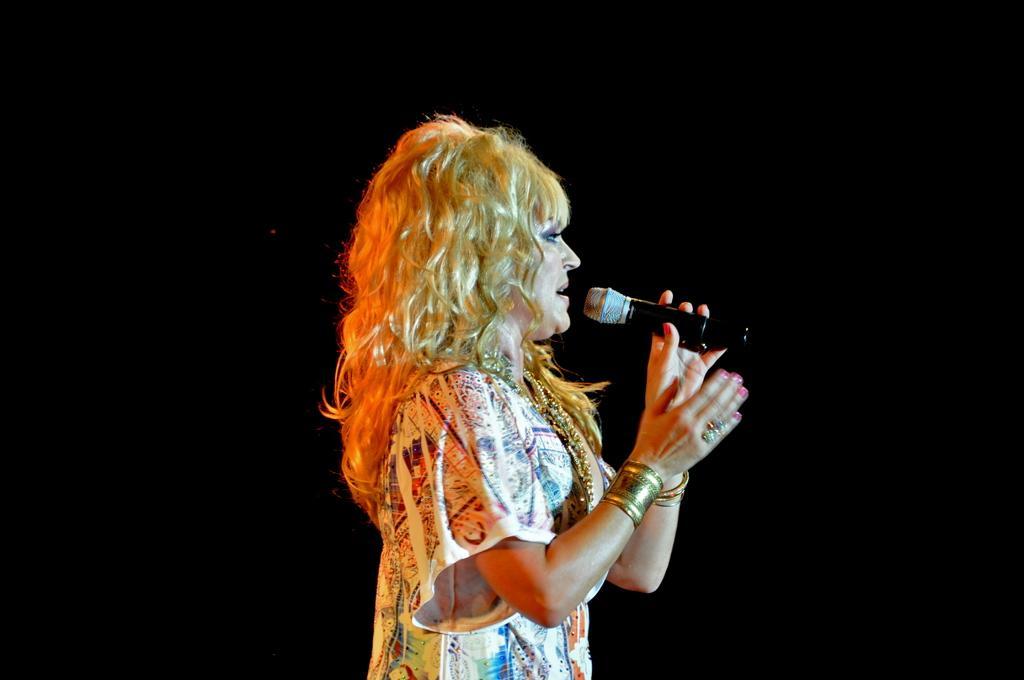Can you describe this image briefly? In this image, woman is holding microphone ,she is singing. 